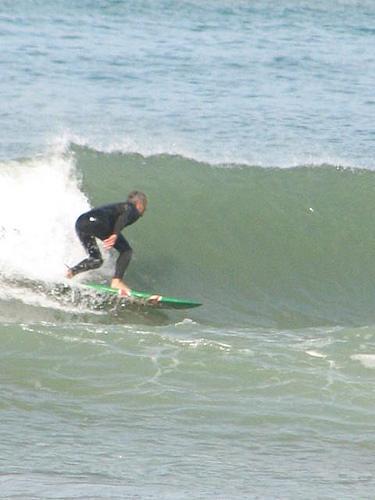How many surfers are pictured?
Give a very brief answer. 1. How many men are there?
Give a very brief answer. 1. How many people are shown?
Give a very brief answer. 1. 